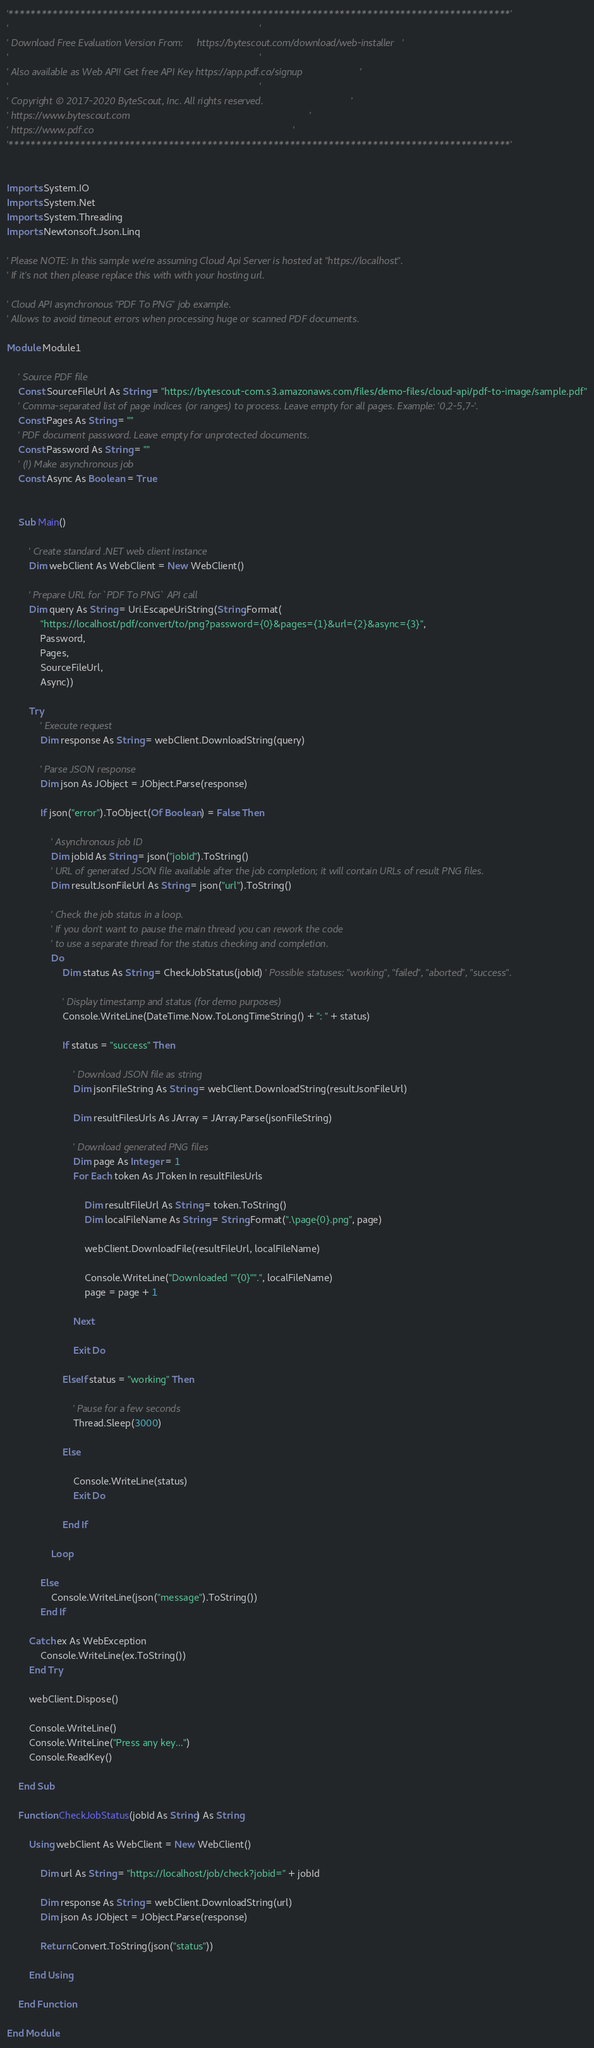<code> <loc_0><loc_0><loc_500><loc_500><_VisualBasic_>'*******************************************************************************************'
'                                                                                           '
' Download Free Evaluation Version From:     https://bytescout.com/download/web-installer   '
'                                                                                           '
' Also available as Web API! Get free API Key https://app.pdf.co/signup                     '
'                                                                                           '
' Copyright © 2017-2020 ByteScout, Inc. All rights reserved.                                '
' https://www.bytescout.com                                                                 '
' https://www.pdf.co                                                                        '
'*******************************************************************************************'


Imports System.IO
Imports System.Net
Imports System.Threading
Imports Newtonsoft.Json.Linq

' Please NOTE: In this sample we're assuming Cloud Api Server is hosted at "https://localhost". 
' If it's not then please replace this with with your hosting url.

' Cloud API asynchronous "PDF To PNG" job example.
' Allows to avoid timeout errors when processing huge or scanned PDF documents.

Module Module1

 	' Source PDF file
	Const SourceFileUrl As String = "https://bytescout-com.s3.amazonaws.com/files/demo-files/cloud-api/pdf-to-image/sample.pdf"
	' Comma-separated list of page indices (or ranges) to process. Leave empty for all pages. Example: '0,2-5,7-'.
	Const Pages As String = ""
	' PDF document password. Leave empty for unprotected documents.
	Const Password As String = ""
	' (!) Make asynchronous job
	Const Async As Boolean = True


	Sub Main()

		' Create standard .NET web client instance
		Dim webClient As WebClient = New WebClient()

		' Prepare URL for `PDF To PNG` API call
		Dim query As String = Uri.EscapeUriString(String.Format(
			"https://localhost/pdf/convert/to/png?password={0}&pages={1}&url={2}&async={3}",
			Password,
			Pages,
			SourceFileUrl,
			Async))

		Try
			' Execute request
			Dim response As String = webClient.DownloadString(query)

			' Parse JSON response
			Dim json As JObject = JObject.Parse(response)

			If json("error").ToObject(Of Boolean) = False Then

				' Asynchronous job ID
				Dim jobId As String = json("jobId").ToString()
				' URL of generated JSON file available after the job completion; it will contain URLs of result PNG files.
				Dim resultJsonFileUrl As String = json("url").ToString()

				' Check the job status in a loop. 
				' If you don't want to pause the main thread you can rework the code 
				' to use a separate thread for the status checking and completion.
				Do
					Dim status As String = CheckJobStatus(jobId) ' Possible statuses: "working", "failed", "aborted", "success".

					' Display timestamp and status (for demo purposes)
					Console.WriteLine(DateTime.Now.ToLongTimeString() + ": " + status)

					If status = "success" Then

						' Download JSON file as string
						Dim jsonFileString As String = webClient.DownloadString(resultJsonFileUrl)

						Dim resultFilesUrls As JArray = JArray.Parse(jsonFileString)

						' Download generated PNG files
						Dim page As Integer = 1
						For Each token As JToken In resultFilesUrls

							Dim resultFileUrl As String = token.ToString()
							Dim localFileName As String = String.Format(".\page{0}.png", page)

							webClient.DownloadFile(resultFileUrl, localFileName)

							Console.WriteLine("Downloaded ""{0}"".", localFileName)
							page = page + 1

						Next

						Exit Do

					ElseIf status = "working" Then

						' Pause for a few seconds
						Thread.Sleep(3000)

					Else

						Console.WriteLine(status)
						Exit Do

					End If

				Loop

			Else
				Console.WriteLine(json("message").ToString())
			End If

		Catch ex As WebException
			Console.WriteLine(ex.ToString())
		End Try

		webClient.Dispose()

		Console.WriteLine()
		Console.WriteLine("Press any key...")
		Console.ReadKey()

	End Sub

	Function CheckJobStatus(jobId As String) As String

		Using webClient As WebClient = New WebClient()

			Dim url As String = "https://localhost/job/check?jobid=" + jobId

			Dim response As String = webClient.DownloadString(url)
			Dim json As JObject = JObject.Parse(response)

			Return Convert.ToString(json("status"))

		End Using

	End Function

End Module
</code> 